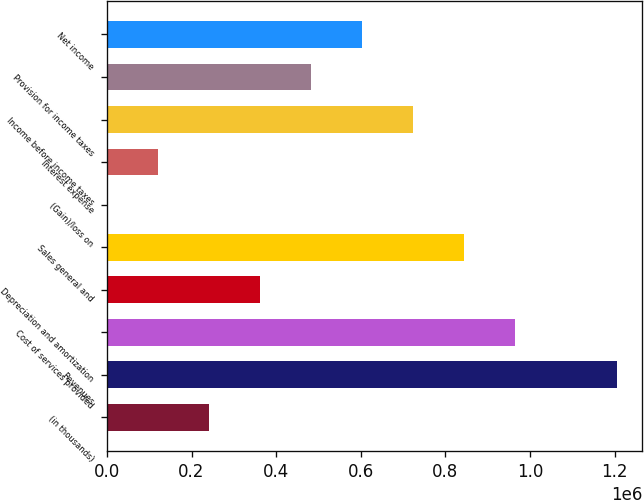Convert chart. <chart><loc_0><loc_0><loc_500><loc_500><bar_chart><fcel>(in thousands)<fcel>Revenues<fcel>Cost of services provided<fcel>Depreciation and amortization<fcel>Sales general and<fcel>(Gain)/loss on<fcel>Interest expense<fcel>Income before income taxes<fcel>Provision for income taxes<fcel>Net income<nl><fcel>241337<fcel>1.20506e+06<fcel>964132<fcel>361803<fcel>843666<fcel>405<fcel>120871<fcel>723200<fcel>482269<fcel>602734<nl></chart> 